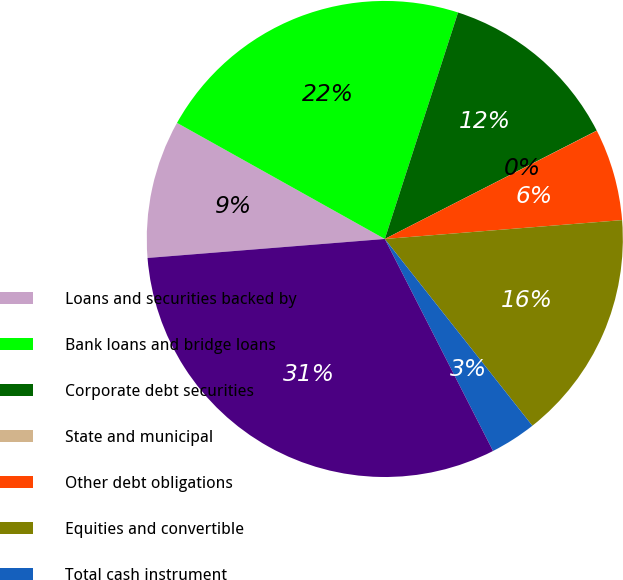<chart> <loc_0><loc_0><loc_500><loc_500><pie_chart><fcel>Loans and securities backed by<fcel>Bank loans and bridge loans<fcel>Corporate debt securities<fcel>State and municipal<fcel>Other debt obligations<fcel>Equities and convertible<fcel>Total cash instrument<fcel>Total cash instrument assets<nl><fcel>9.38%<fcel>21.87%<fcel>12.5%<fcel>0.01%<fcel>6.25%<fcel>15.62%<fcel>3.13%<fcel>31.24%<nl></chart> 